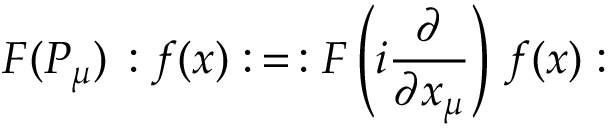<formula> <loc_0><loc_0><loc_500><loc_500>F ( P _ { \mu } ) \, \colon f ( x ) \colon \, = \, \colon F \left ( i \frac { \partial } { \partial x _ { \mu } } \right ) \, f ( x ) \colon</formula> 